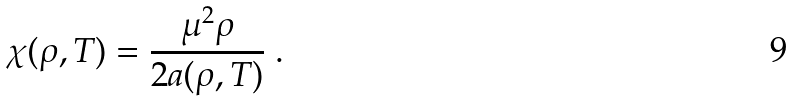Convert formula to latex. <formula><loc_0><loc_0><loc_500><loc_500>\chi ( \rho , T ) = \frac { \mu ^ { 2 } \rho } { 2 a ( \rho , T ) } \ .</formula> 